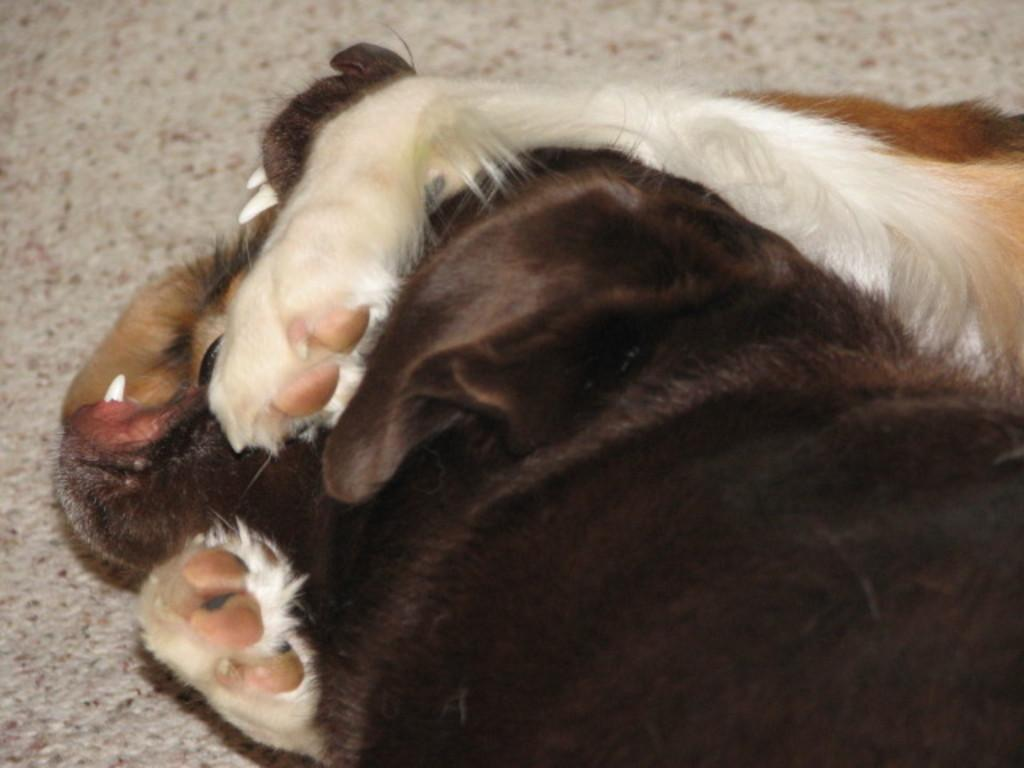How many dogs are present in the image? There are two dogs in the image. Can you describe the appearance of the dogs? One dog is white, and the other is black. What is the color of the carpet or floor in the background of the image? There is a grey carpet or floor in the background of the image. What type of rock can be seen in the image? There is no rock present in the image; it features two dogs on a grey carpet or floor. How many bears are visible in the image? There are no bears present in the image; it features two dogs on a grey carpet or floor. 